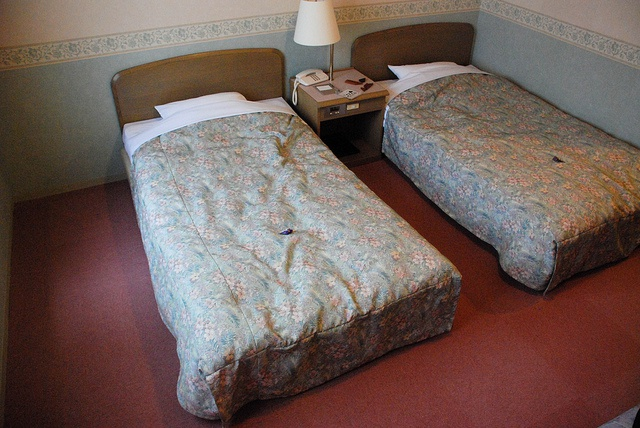Describe the objects in this image and their specific colors. I can see bed in black, darkgray, lightgray, and maroon tones and bed in black, gray, and darkgray tones in this image. 